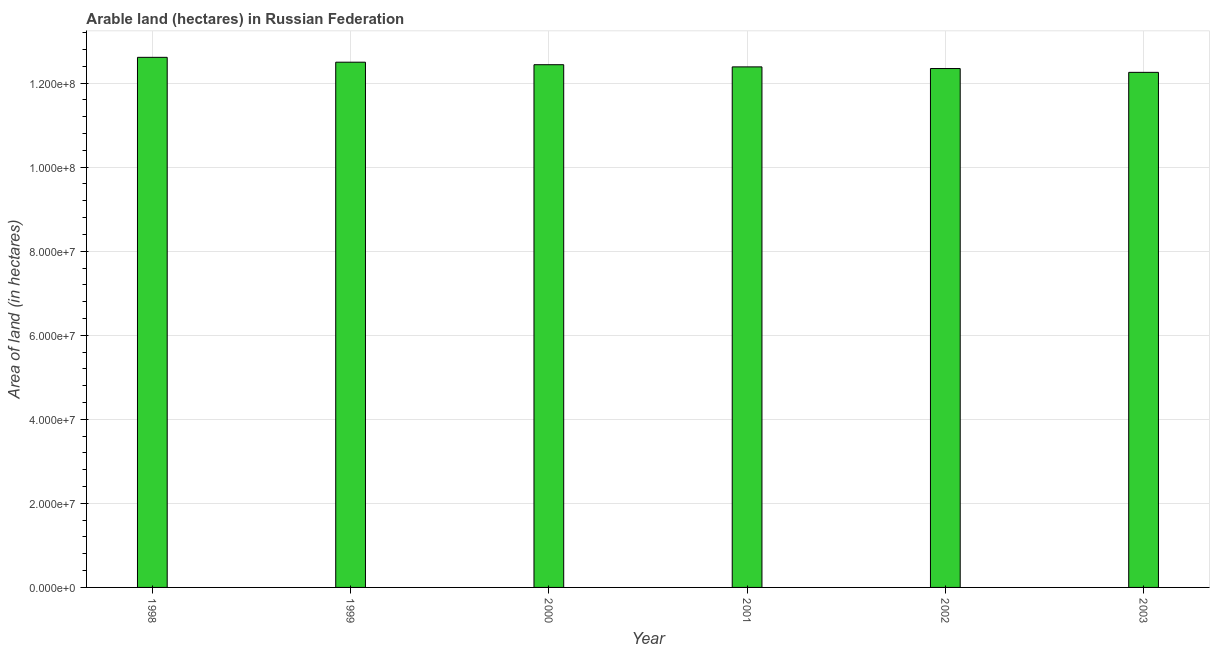Does the graph contain any zero values?
Ensure brevity in your answer.  No. Does the graph contain grids?
Your answer should be compact. Yes. What is the title of the graph?
Provide a succinct answer. Arable land (hectares) in Russian Federation. What is the label or title of the X-axis?
Make the answer very short. Year. What is the label or title of the Y-axis?
Ensure brevity in your answer.  Area of land (in hectares). What is the area of land in 2003?
Offer a very short reply. 1.23e+08. Across all years, what is the maximum area of land?
Give a very brief answer. 1.26e+08. Across all years, what is the minimum area of land?
Your answer should be very brief. 1.23e+08. In which year was the area of land maximum?
Make the answer very short. 1998. What is the sum of the area of land?
Provide a succinct answer. 7.45e+08. What is the difference between the area of land in 2001 and 2003?
Offer a terse response. 1.30e+06. What is the average area of land per year?
Your answer should be very brief. 1.24e+08. What is the median area of land?
Make the answer very short. 1.24e+08. Do a majority of the years between 2002 and 2003 (inclusive) have area of land greater than 96000000 hectares?
Keep it short and to the point. Yes. Is the area of land in 1998 less than that in 1999?
Your answer should be very brief. No. What is the difference between the highest and the second highest area of land?
Your answer should be very brief. 1.16e+06. Is the sum of the area of land in 1999 and 2000 greater than the maximum area of land across all years?
Give a very brief answer. Yes. What is the difference between the highest and the lowest area of land?
Your answer should be compact. 3.57e+06. In how many years, is the area of land greater than the average area of land taken over all years?
Your response must be concise. 3. How many bars are there?
Your answer should be compact. 6. Are all the bars in the graph horizontal?
Keep it short and to the point. No. Are the values on the major ticks of Y-axis written in scientific E-notation?
Your answer should be very brief. Yes. What is the Area of land (in hectares) of 1998?
Keep it short and to the point. 1.26e+08. What is the Area of land (in hectares) of 1999?
Your response must be concise. 1.25e+08. What is the Area of land (in hectares) of 2000?
Your response must be concise. 1.24e+08. What is the Area of land (in hectares) of 2001?
Offer a very short reply. 1.24e+08. What is the Area of land (in hectares) of 2002?
Your answer should be very brief. 1.23e+08. What is the Area of land (in hectares) in 2003?
Your answer should be very brief. 1.23e+08. What is the difference between the Area of land (in hectares) in 1998 and 1999?
Offer a very short reply. 1.16e+06. What is the difference between the Area of land (in hectares) in 1998 and 2000?
Provide a short and direct response. 1.76e+06. What is the difference between the Area of land (in hectares) in 1998 and 2001?
Offer a very short reply. 2.27e+06. What is the difference between the Area of land (in hectares) in 1998 and 2002?
Offer a very short reply. 2.67e+06. What is the difference between the Area of land (in hectares) in 1998 and 2003?
Ensure brevity in your answer.  3.57e+06. What is the difference between the Area of land (in hectares) in 1999 and 2000?
Offer a terse response. 6.01e+05. What is the difference between the Area of land (in hectares) in 1999 and 2001?
Provide a short and direct response. 1.12e+06. What is the difference between the Area of land (in hectares) in 1999 and 2002?
Your answer should be very brief. 1.51e+06. What is the difference between the Area of land (in hectares) in 1999 and 2003?
Your response must be concise. 2.42e+06. What is the difference between the Area of land (in hectares) in 2000 and 2001?
Your answer should be very brief. 5.14e+05. What is the difference between the Area of land (in hectares) in 2000 and 2002?
Your answer should be compact. 9.09e+05. What is the difference between the Area of land (in hectares) in 2000 and 2003?
Your answer should be very brief. 1.82e+06. What is the difference between the Area of land (in hectares) in 2001 and 2002?
Ensure brevity in your answer.  3.95e+05. What is the difference between the Area of land (in hectares) in 2001 and 2003?
Provide a short and direct response. 1.30e+06. What is the difference between the Area of land (in hectares) in 2002 and 2003?
Your answer should be very brief. 9.06e+05. What is the ratio of the Area of land (in hectares) in 1998 to that in 1999?
Keep it short and to the point. 1.01. What is the ratio of the Area of land (in hectares) in 1998 to that in 2000?
Ensure brevity in your answer.  1.01. What is the ratio of the Area of land (in hectares) in 1999 to that in 2001?
Your answer should be compact. 1.01. What is the ratio of the Area of land (in hectares) in 1999 to that in 2003?
Provide a short and direct response. 1.02. What is the ratio of the Area of land (in hectares) in 2000 to that in 2001?
Ensure brevity in your answer.  1. What is the ratio of the Area of land (in hectares) in 2000 to that in 2003?
Your answer should be very brief. 1.01. What is the ratio of the Area of land (in hectares) in 2001 to that in 2003?
Provide a short and direct response. 1.01. What is the ratio of the Area of land (in hectares) in 2002 to that in 2003?
Your answer should be very brief. 1.01. 